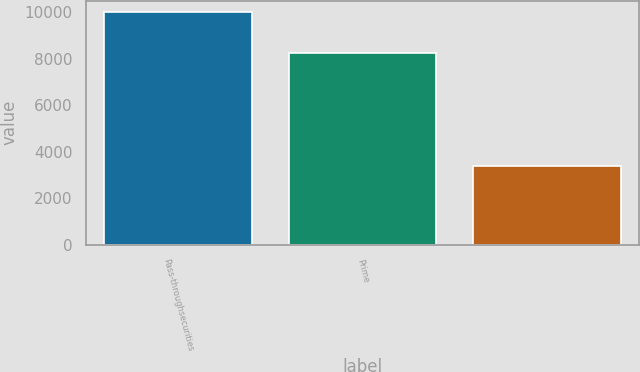Convert chart. <chart><loc_0><loc_0><loc_500><loc_500><bar_chart><fcel>Pass-throughsecurities<fcel>Prime<fcel>Unnamed: 2<nl><fcel>10003<fcel>8254<fcel>3365<nl></chart> 